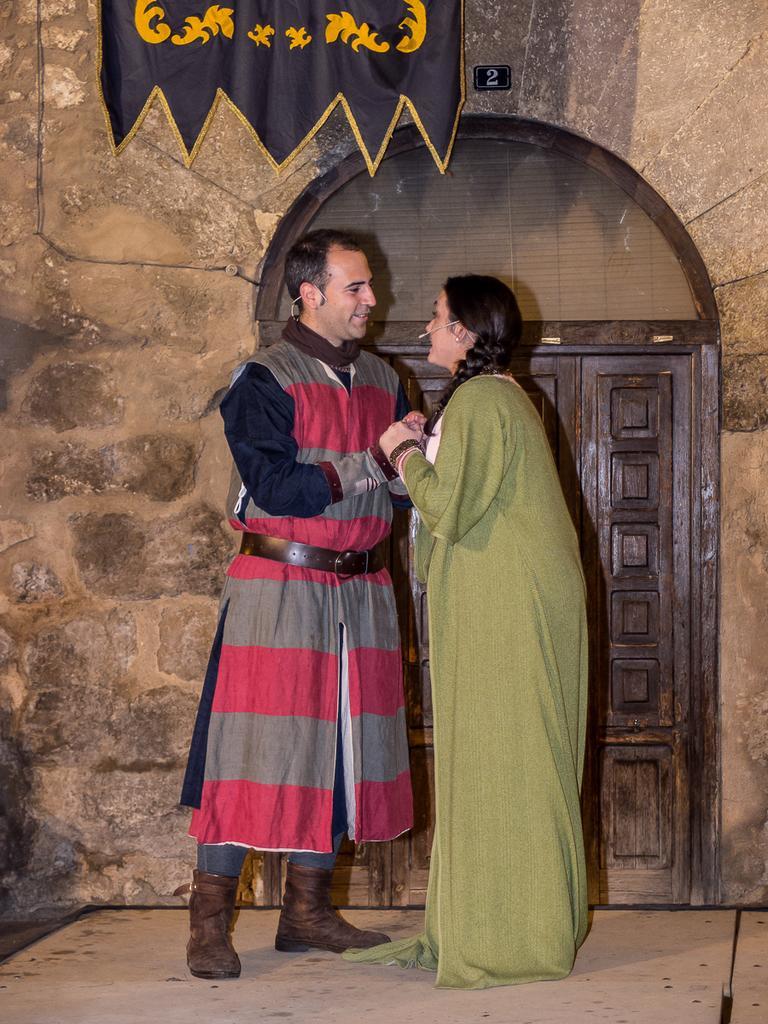In one or two sentences, can you explain what this image depicts? In this image we can see a lady holding the hands of a person, there is a door and a cloth, also we can see the wall. 